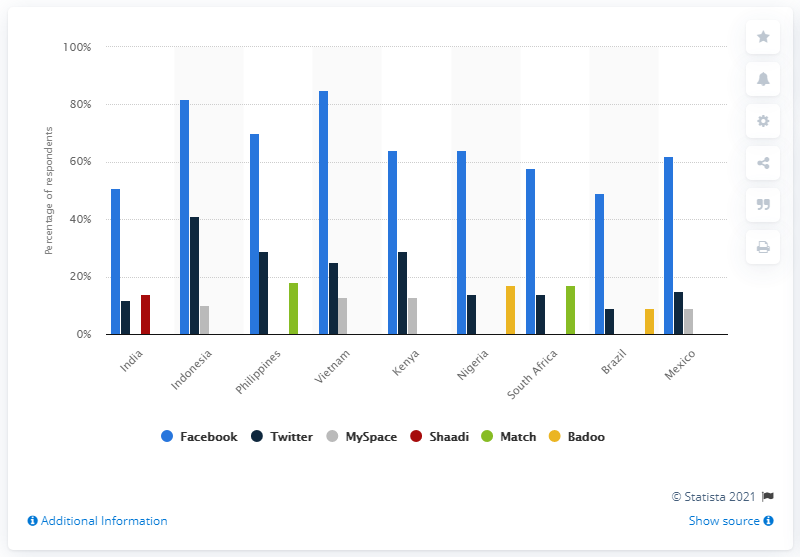Draw attention to some important aspects in this diagram. According to the survey, nine percent of respondents from Brazil reported using Twitter to find a partner. 